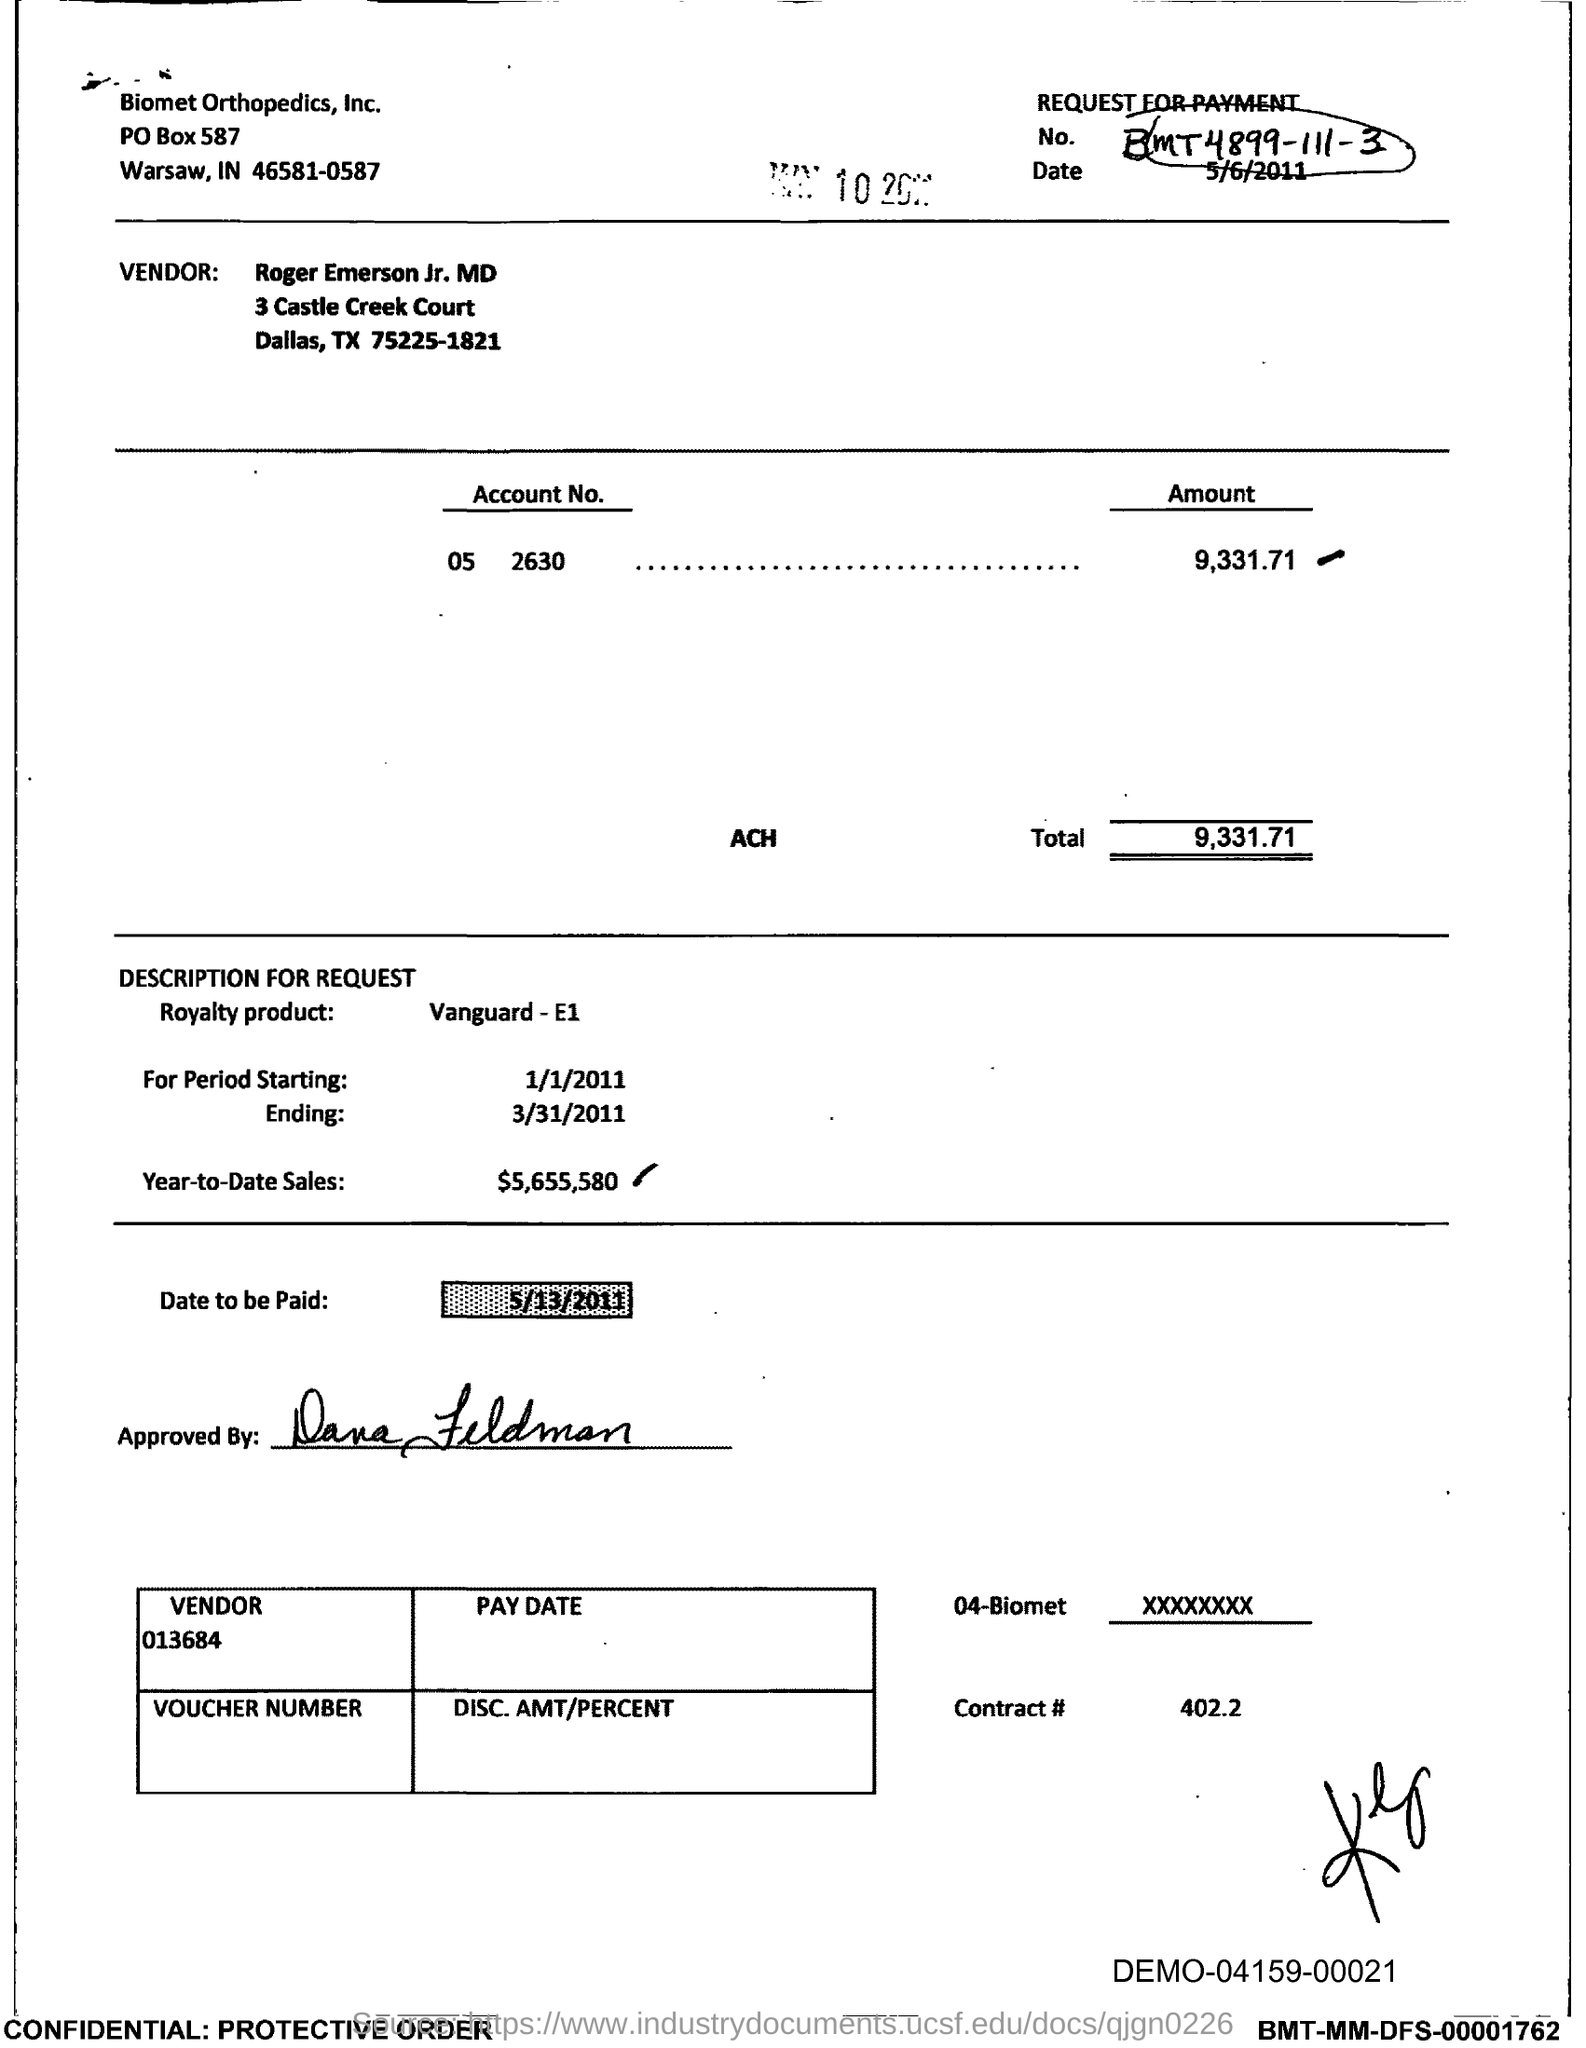Specify some key components in this picture. The request for payment no. given in the document is BMT4899-111-3.. In the document, the royalty product mentioned is Vanguard E1. The total amount to be paid, as specified in the document, is 9,331.71... The contract number as mentioned in the document is 402.2. The start date of the royalty period is January 1, 2011. 